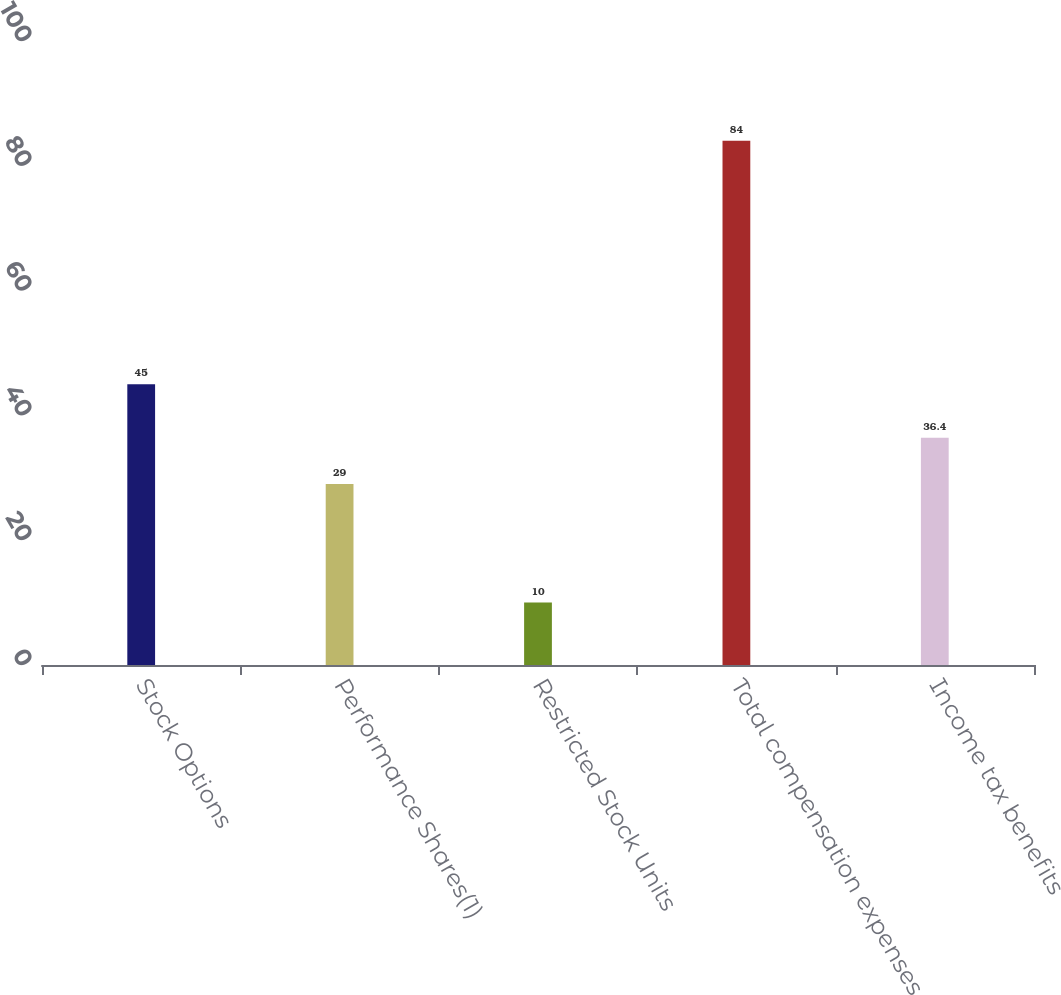Convert chart to OTSL. <chart><loc_0><loc_0><loc_500><loc_500><bar_chart><fcel>Stock Options<fcel>Performance Shares(1)<fcel>Restricted Stock Units<fcel>Total compensation expenses<fcel>Income tax benefits<nl><fcel>45<fcel>29<fcel>10<fcel>84<fcel>36.4<nl></chart> 